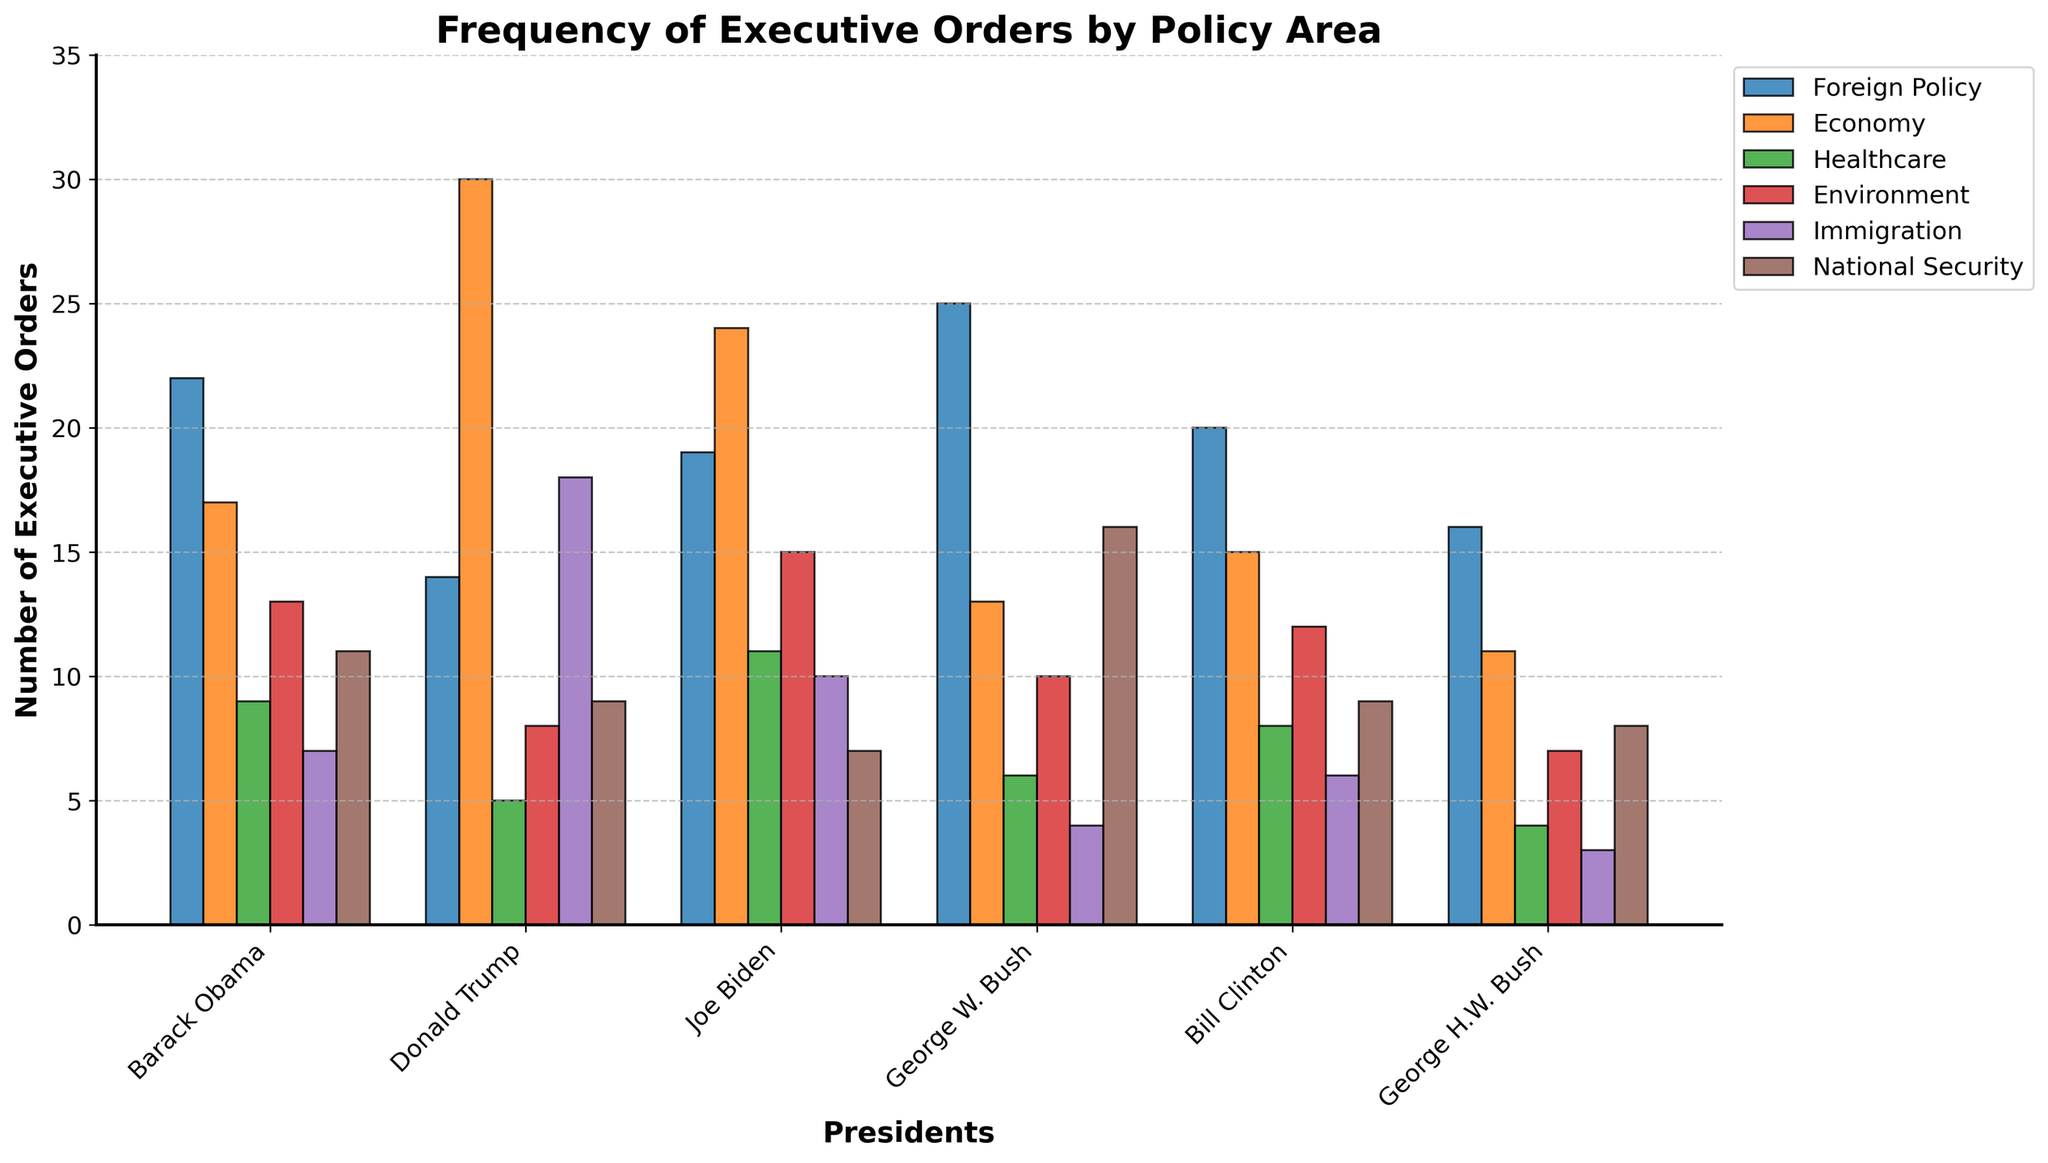Which president issued the most executive orders related to the Economy? To find this, we compare the bar heights for each president in the 'Economy' category. Trump has the highest value with 30 executive orders.
Answer: Donald Trump What is the total number of executive orders issued by Joe Biden in Foreign Policy and Immigration combined? Add the values from the 'Foreign Policy' and 'Immigration' bars for Joe Biden. The sum is 19 (Foreign Policy) + 10 (Immigration) = 29.
Answer: 29 Who issued more executive orders on National Security, George W. Bush or Barack Obama? Compare the 'National Security' bars for George W. Bush and Barack Obama. George W. Bush has 16, while Barack Obama has 11.
Answer: George W. Bush Which policy area has the highest number of executive orders for Bill Clinton? Identify the tallest bar for Bill Clinton. The 'Environment' bar is highest at 12.
Answer: Environment What is the difference in the number of executive orders on Healthcare between Barack Obama and George H.W. Bush? Subtract George H.W. Bush's 'Healthcare' value from Barack Obama's 'Healthcare' value. The calculation is 9 (Obama) - 4 (George H.W. Bush) = 5.
Answer: 5 Among the presidents listed, who issued the fewest executive orders related to Immigration? Identify the shortest bar in the 'Immigration' category. George H.W. Bush issued the fewest with 3.
Answer: George H.W. Bush How many more executive orders were issued by Donald Trump on Economy than on Environment? Subtract the 'Environment' value from the 'Economy' value for Donald Trump. The calculation is 30 (Economy) - 8 (Environment) = 22.
Answer: 22 Which president issued the highest number of combined executive orders in Healthcare and National Security? Sum the 'Healthcare' and 'National Security' values for each president and compare. George W. Bush has the highest combined total of 6 (Healthcare) + 16 (National Security) = 22.
Answer: George W. Bush How many total executive orders related to the Foreign Policy were issued by all the presidents combined? Sum the 'Foreign Policy' values for all presidents. The calculation is 22 (Obama) + 14 (Trump) + 19 (Biden) + 25 (George W. Bush) + 20 (Clinton) + 16 (George H.W. Bush) = 116.
Answer: 116 Which two policy areas have the same number of executive orders for George H.W. Bush? Compare the heights of the bars for George H.W. Bush. 'Immigration' and 'National Security' both have 8 executive orders.
Answer: Immigration and National Security 